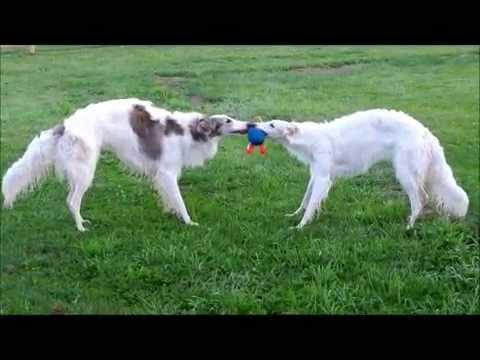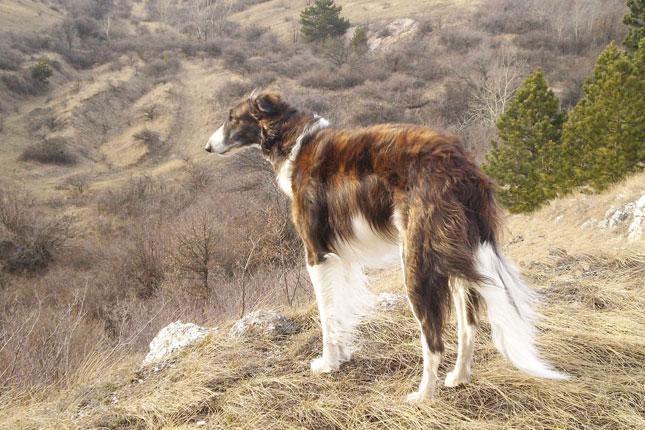The first image is the image on the left, the second image is the image on the right. Assess this claim about the two images: "Three dogs are standing in the green grass.". Correct or not? Answer yes or no. No. The first image is the image on the left, the second image is the image on the right. Assess this claim about the two images: "An image shows one hound standing in profile with body turned leftward, on green grass in front of a manmade structure.". Correct or not? Answer yes or no. No. 